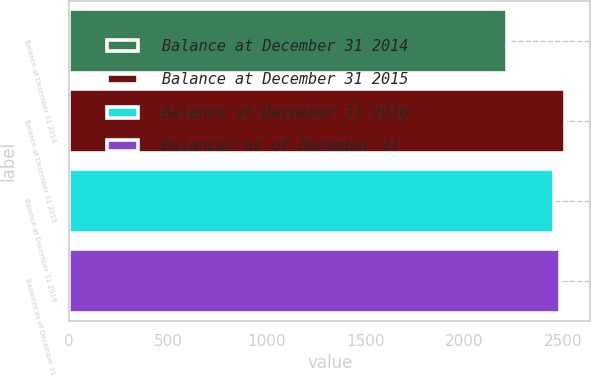Convert chart. <chart><loc_0><loc_0><loc_500><loc_500><bar_chart><fcel>Balance at December 31 2014<fcel>Balance at December 31 2015<fcel>Balance at December 31 2016<fcel>Balances as of December 31<nl><fcel>2217.6<fcel>2511.56<fcel>2455<fcel>2483.28<nl></chart> 